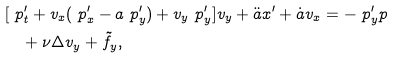Convert formula to latex. <formula><loc_0><loc_0><loc_500><loc_500>& [ \ p _ { t } ^ { \prime } + v _ { x } ( \ p _ { x } ^ { \prime } - a \ p _ { y } ^ { \prime } ) + v _ { y } \ p _ { y } ^ { \prime } ] v _ { y } + \ddot { a } x ^ { \prime } + \dot { a } v _ { x } = - \ p _ { y } ^ { \prime } p \\ & \quad + \nu \Delta v _ { y } + \tilde { f } _ { y } ,</formula> 